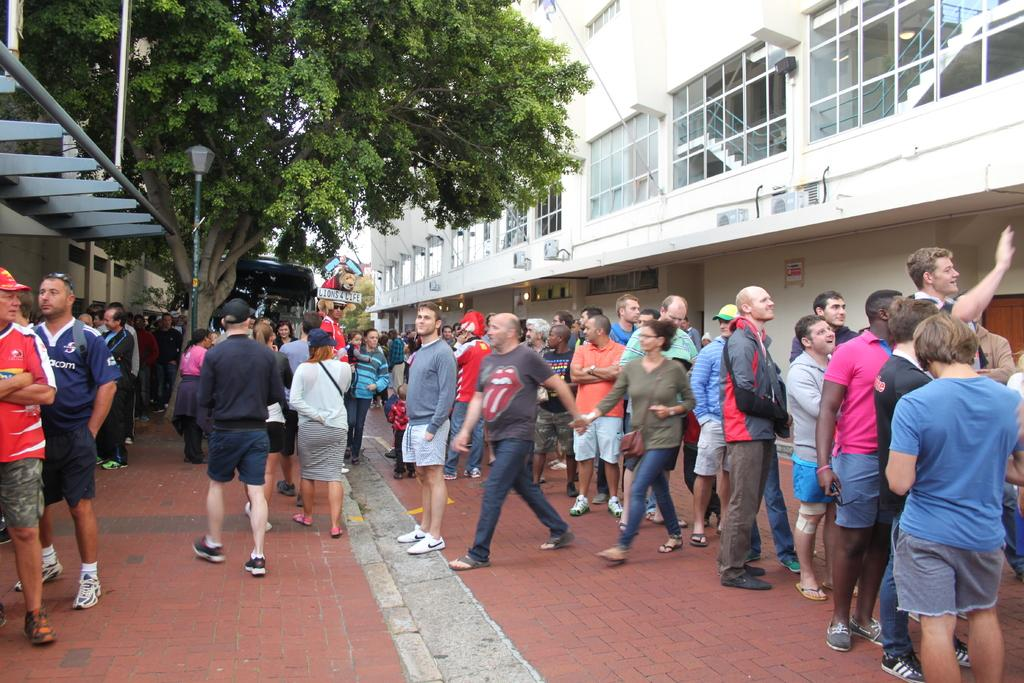What is the main subject of the image? The main subject of the image is a crowd. What can be seen in the background of the image? In the background of the image, there are trees, a pole, a light, and buildings. Can you describe the setting of the image? The image appears to be set in an urban area with buildings and trees in the background. How many boys are sitting on the oven in the image? There is no oven present in the image, and therefore no boys are sitting on it. 